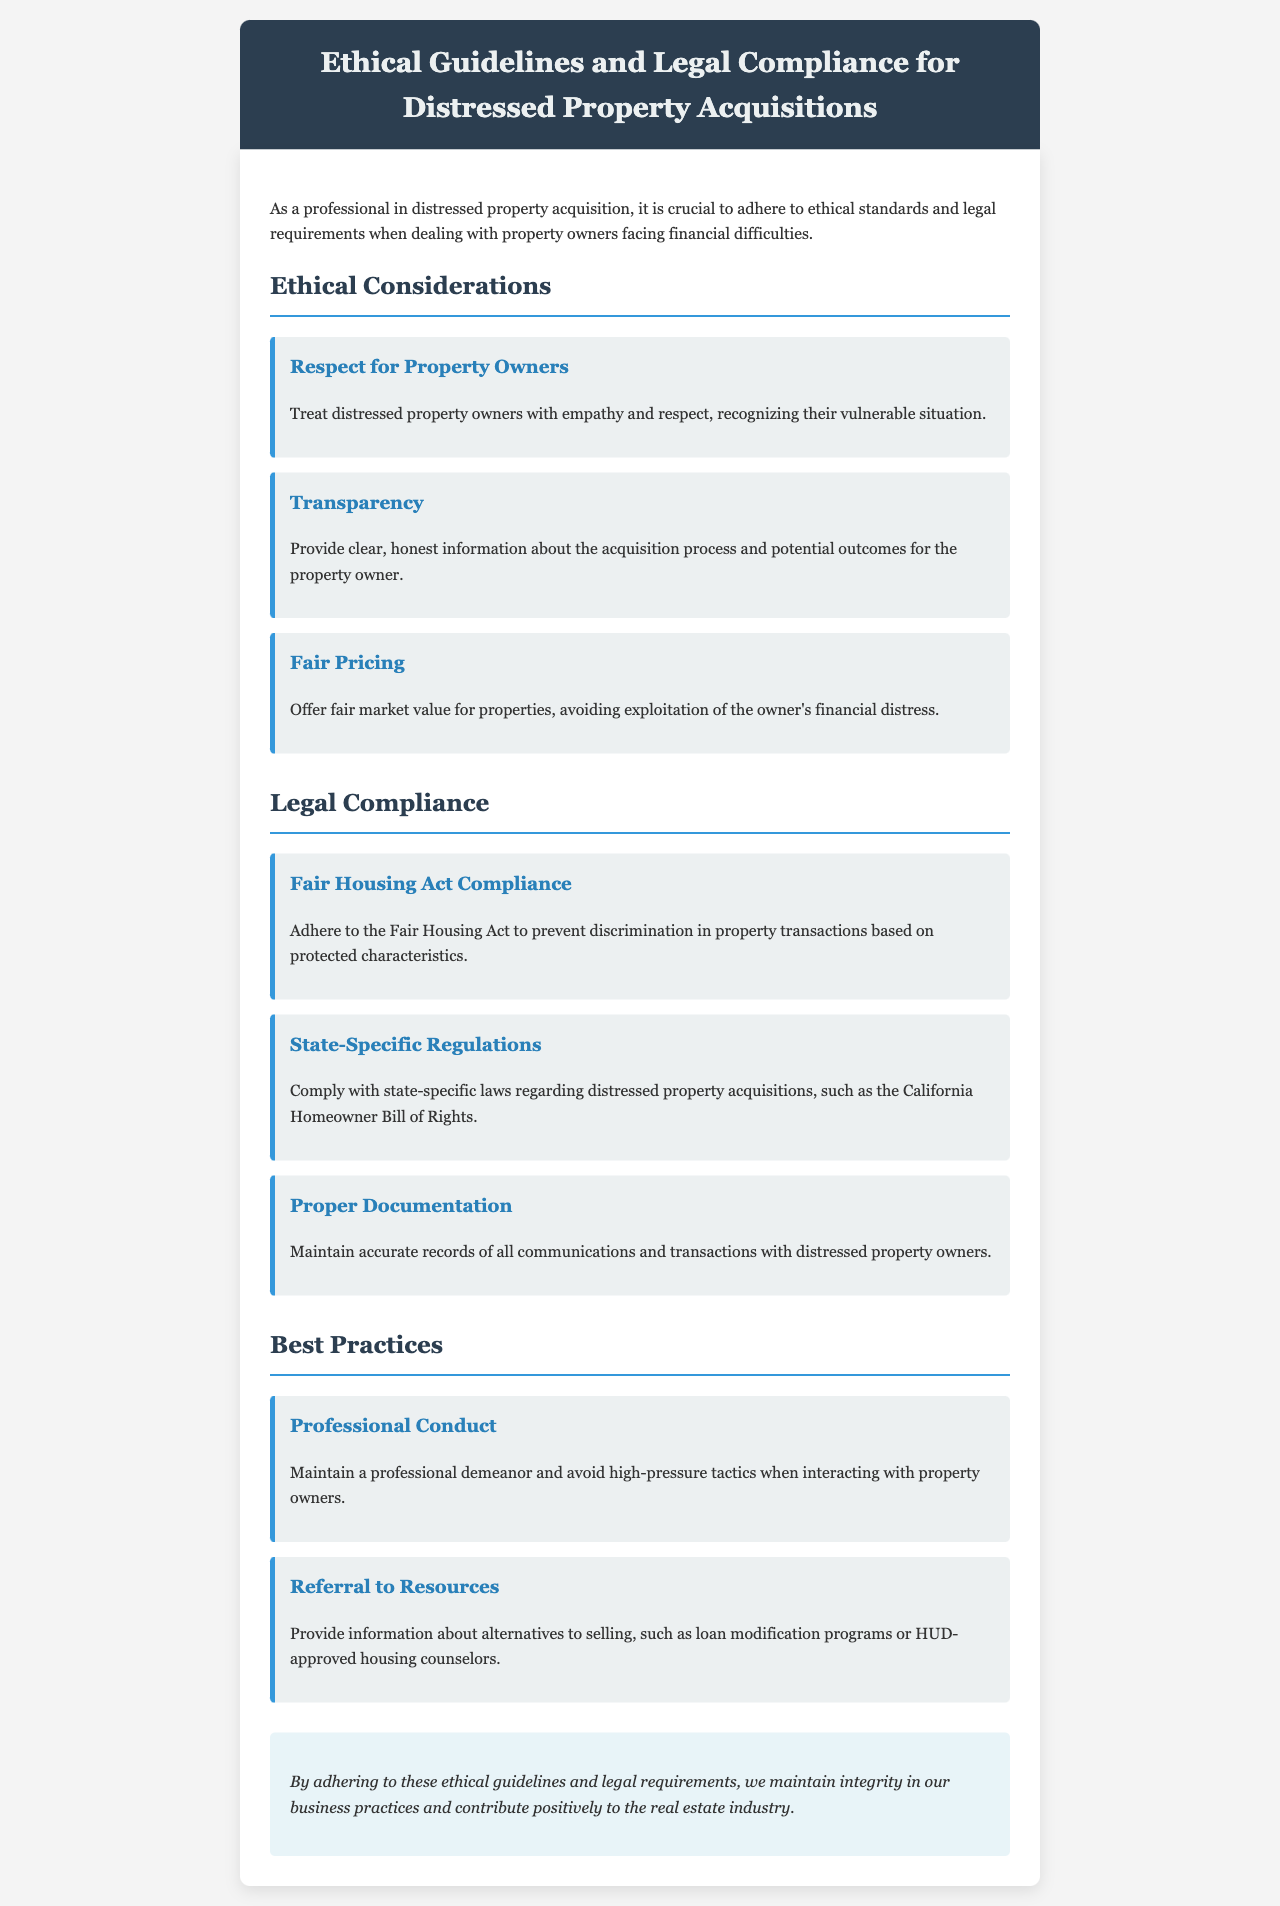what is the title of the document? The title is specifically mentioned in the header of the document, which outlines the main focus.
Answer: Ethical Guidelines and Legal Compliance for Distressed Property Acquisitions what are the ethical considerations listed in the document? The ethical considerations are divided into three distinct categories presented in the "Ethical Considerations" section.
Answer: Respect for Property Owners, Transparency, Fair Pricing how many legal compliance categories are mentioned? The document outlines specific legal compliance categories that fall under a heading in the "Legal Compliance" section.
Answer: Three which act must be complied with to prevent discrimination? The act is referenced as critical for maintaining fairness in property transactions, emphasized in the legal compliance section.
Answer: Fair Housing Act what is one best practice suggested in the document? The best practices section contains multiple suggestions for ethical dealings, highlighting expected professional behavior.
Answer: Professional Conduct what is the focus of the conclusion in the document? The conclusion reiterates the importance of the previous sections for maintaining integrity in practices related to distressed property acquisitions.
Answer: Integrity in business practices what does the document encourage regarding information for owners? The document promotes providing support and resources to owners facing challenges, as discussed in the best practices section.
Answer: Referral to Resources what should be maintained for all interactions with owners? The document emphasizes the importance of accurate maintenance regarding the dealings with property owners.
Answer: Proper Documentation 